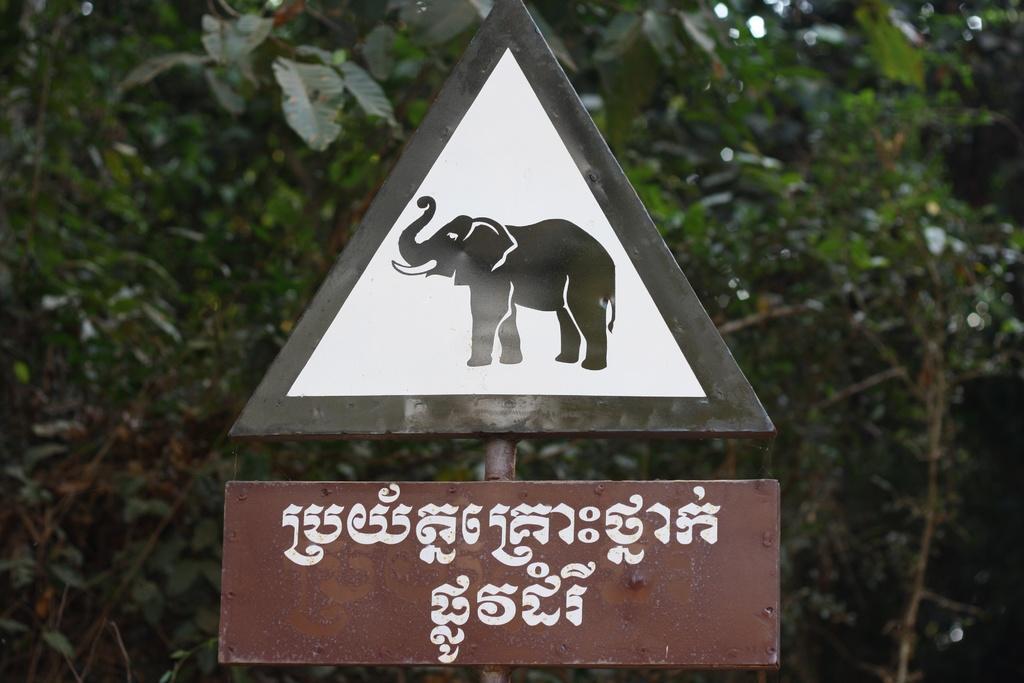In one or two sentences, can you explain what this image depicts? In this image we can see sign boards on the pole and we can also see some trees. 